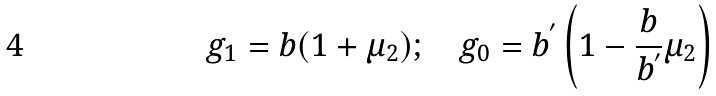Convert formula to latex. <formula><loc_0><loc_0><loc_500><loc_500>g _ { 1 } = b ( 1 + \mu _ { 2 } ) ; \quad g _ { 0 } = b ^ { ^ { \prime } } \left ( 1 - \frac { b } { b ^ { ^ { \prime } } } \mu _ { 2 } \right )</formula> 